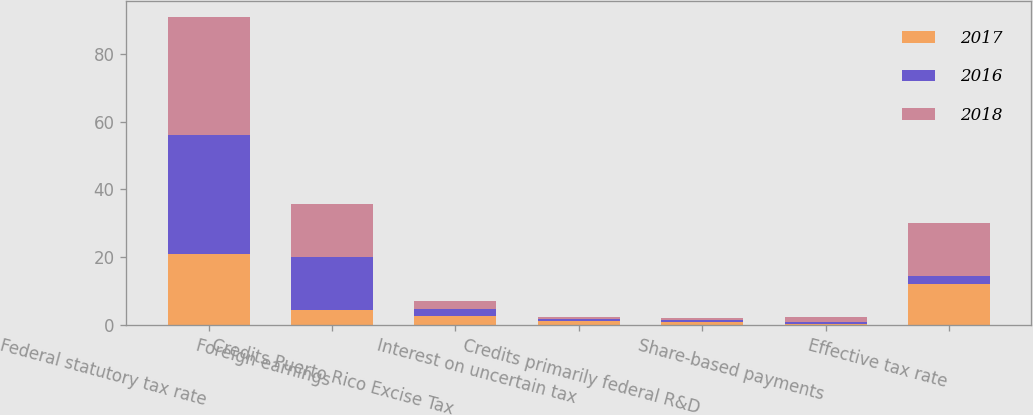<chart> <loc_0><loc_0><loc_500><loc_500><stacked_bar_chart><ecel><fcel>Federal statutory tax rate<fcel>Foreign earnings<fcel>Credits Puerto Rico Excise Tax<fcel>Interest on uncertain tax<fcel>Credits primarily federal R&D<fcel>Share-based payments<fcel>Effective tax rate<nl><fcel>2017<fcel>21<fcel>4.3<fcel>2.5<fcel>1.2<fcel>0.8<fcel>0.2<fcel>12.1<nl><fcel>2016<fcel>35<fcel>15.8<fcel>2.2<fcel>0.6<fcel>0.6<fcel>0.7<fcel>2.25<nl><fcel>2018<fcel>35<fcel>15.5<fcel>2.3<fcel>0.5<fcel>0.7<fcel>1.3<fcel>15.7<nl></chart> 